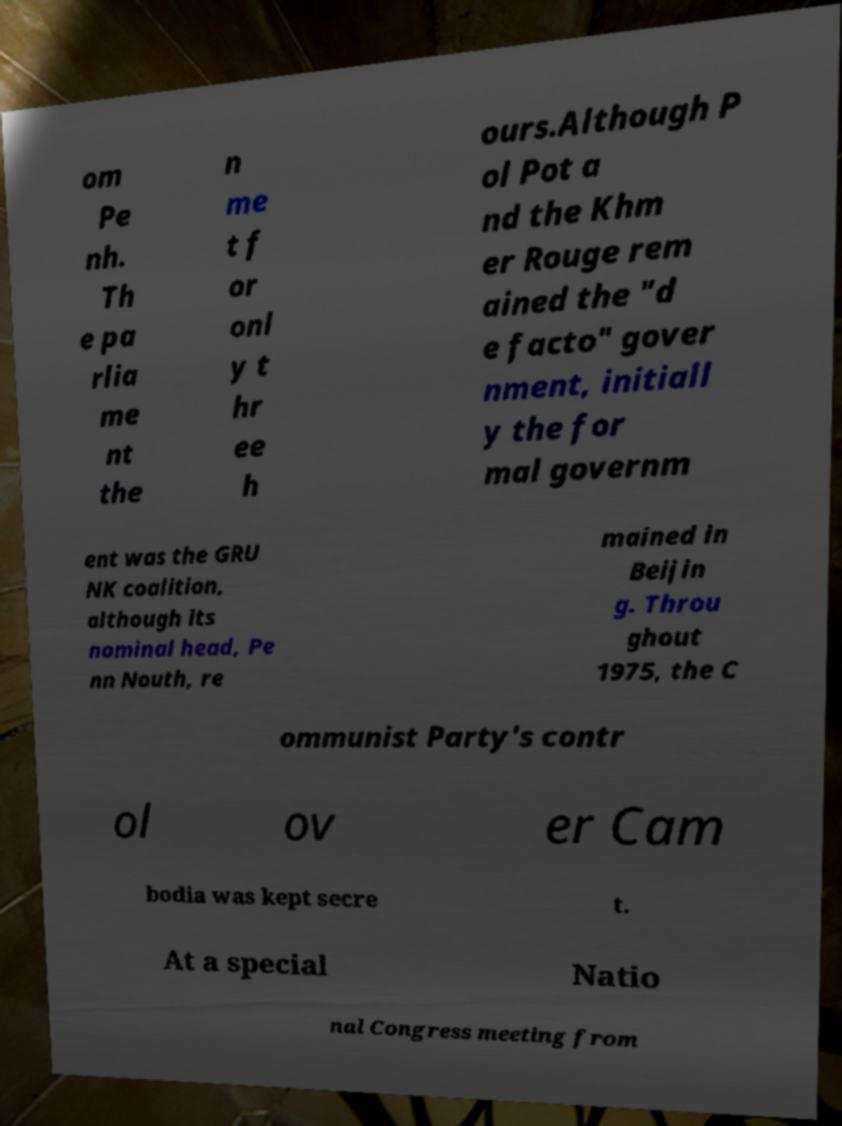Can you read and provide the text displayed in the image?This photo seems to have some interesting text. Can you extract and type it out for me? om Pe nh. Th e pa rlia me nt the n me t f or onl y t hr ee h ours.Although P ol Pot a nd the Khm er Rouge rem ained the "d e facto" gover nment, initiall y the for mal governm ent was the GRU NK coalition, although its nominal head, Pe nn Nouth, re mained in Beijin g. Throu ghout 1975, the C ommunist Party's contr ol ov er Cam bodia was kept secre t. At a special Natio nal Congress meeting from 